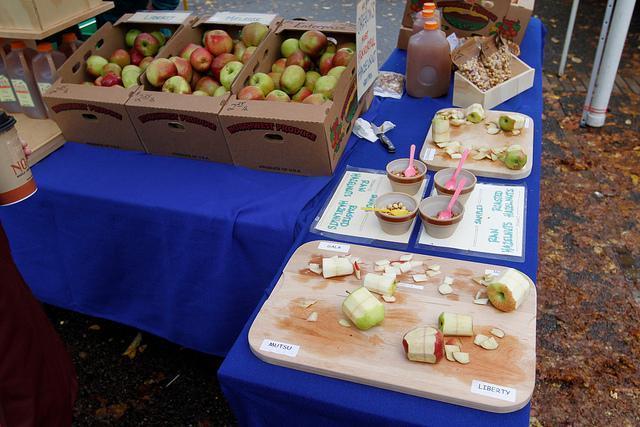How many pink spoons are there?
Give a very brief answer. 3. How many apples are there?
Give a very brief answer. 3. How many bottles are visible?
Give a very brief answer. 2. 